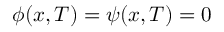Convert formula to latex. <formula><loc_0><loc_0><loc_500><loc_500>\phi ( x , T ) = \psi ( x , T ) = 0</formula> 